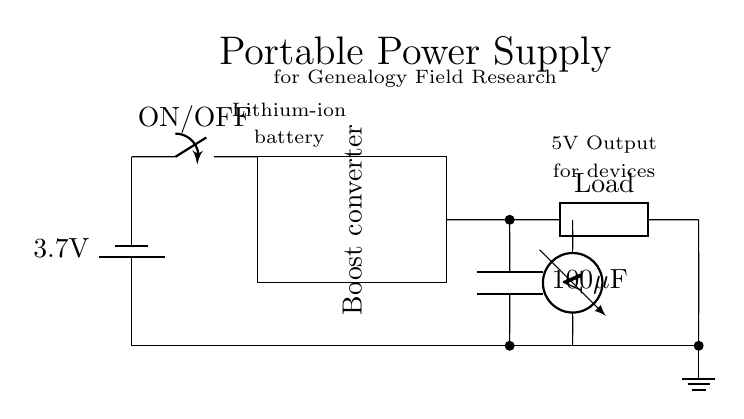What is the battery voltage? The battery in the circuit diagram is labeled with a voltage of 3.7 volts, indicating that this is its potential difference.
Answer: 3.7 volts What type of switch is used in this circuit? The circuit uses an ON/OFF switch, as indicated by the label on the switch component in the diagram.
Answer: ON/OFF What is the purpose of the boost converter? The boost converter is designed to increase the voltage from the battery to the necessary operating voltage for the load, which is typically higher than the battery voltage.
Answer: Increase voltage What is the capacitor value in this circuit? The capacitor is labeled with a value of 100 microfarads, indicating its capacitance as specified in the diagram.
Answer: 100 microfarads What is the output voltage for devices connected to this power supply? The voltage output for devices is specified as 5V in the circuit, indicating the potential difference supplied to connected devices.
Answer: 5 volts How is the load connected in this circuit? The load is connected in series after the output capacitor, receiving the boosted voltage from the boost converter before returning to ground.
Answer: In series Why is a voltmeter included in this circuit? The voltmeter is included to measure the voltage across the load, allowing users to verify that the output meets the expected voltage level required for the device operation.
Answer: Measure voltage 